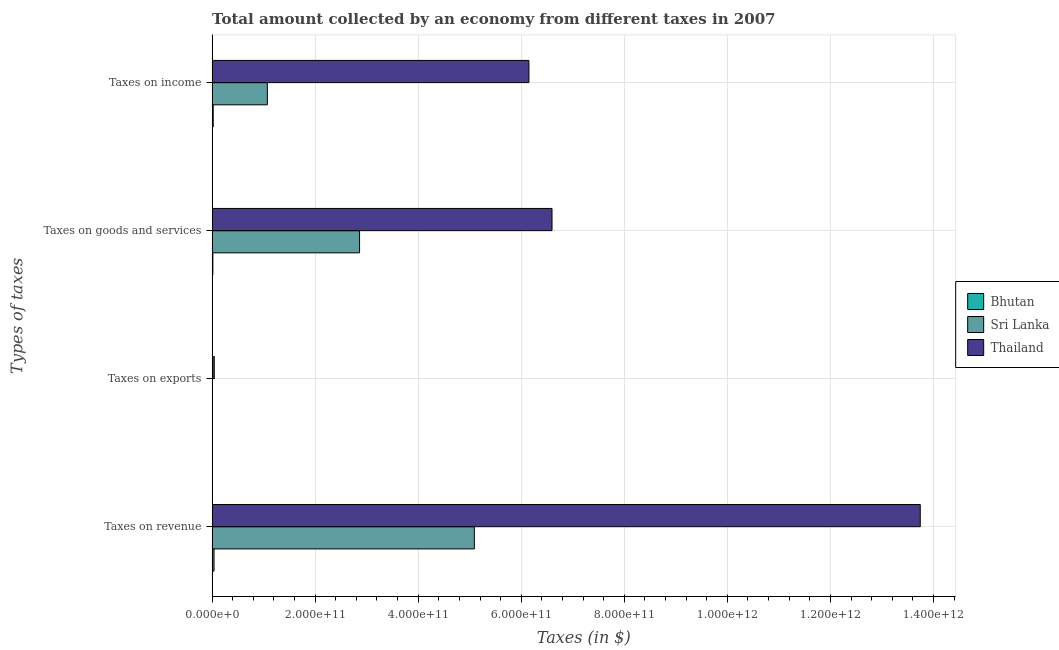How many different coloured bars are there?
Make the answer very short. 3. How many bars are there on the 2nd tick from the top?
Provide a succinct answer. 3. How many bars are there on the 1st tick from the bottom?
Provide a short and direct response. 3. What is the label of the 2nd group of bars from the top?
Ensure brevity in your answer.  Taxes on goods and services. What is the amount collected as tax on revenue in Thailand?
Offer a very short reply. 1.37e+12. Across all countries, what is the maximum amount collected as tax on exports?
Your answer should be compact. 4.16e+09. Across all countries, what is the minimum amount collected as tax on goods?
Offer a terse response. 1.42e+09. In which country was the amount collected as tax on revenue maximum?
Provide a short and direct response. Thailand. In which country was the amount collected as tax on exports minimum?
Your answer should be compact. Bhutan. What is the total amount collected as tax on goods in the graph?
Your answer should be compact. 9.47e+11. What is the difference between the amount collected as tax on exports in Thailand and that in Bhutan?
Offer a very short reply. 4.16e+09. What is the difference between the amount collected as tax on exports in Thailand and the amount collected as tax on income in Sri Lanka?
Your response must be concise. -1.03e+11. What is the average amount collected as tax on revenue per country?
Keep it short and to the point. 6.29e+11. What is the difference between the amount collected as tax on goods and amount collected as tax on revenue in Thailand?
Keep it short and to the point. -7.15e+11. In how many countries, is the amount collected as tax on goods greater than 1040000000000 $?
Provide a short and direct response. 0. What is the ratio of the amount collected as tax on revenue in Thailand to that in Sri Lanka?
Offer a terse response. 2.7. What is the difference between the highest and the second highest amount collected as tax on income?
Give a very brief answer. 5.08e+11. What is the difference between the highest and the lowest amount collected as tax on exports?
Ensure brevity in your answer.  4.16e+09. In how many countries, is the amount collected as tax on exports greater than the average amount collected as tax on exports taken over all countries?
Your answer should be very brief. 1. Is the sum of the amount collected as tax on revenue in Bhutan and Sri Lanka greater than the maximum amount collected as tax on goods across all countries?
Give a very brief answer. No. Is it the case that in every country, the sum of the amount collected as tax on goods and amount collected as tax on income is greater than the sum of amount collected as tax on exports and amount collected as tax on revenue?
Keep it short and to the point. No. What does the 2nd bar from the top in Taxes on exports represents?
Make the answer very short. Sri Lanka. What does the 3rd bar from the bottom in Taxes on revenue represents?
Provide a succinct answer. Thailand. What is the difference between two consecutive major ticks on the X-axis?
Your answer should be very brief. 2.00e+11. Does the graph contain any zero values?
Your response must be concise. No. How many legend labels are there?
Your response must be concise. 3. How are the legend labels stacked?
Make the answer very short. Vertical. What is the title of the graph?
Offer a terse response. Total amount collected by an economy from different taxes in 2007. Does "Venezuela" appear as one of the legend labels in the graph?
Your response must be concise. No. What is the label or title of the X-axis?
Give a very brief answer. Taxes (in $). What is the label or title of the Y-axis?
Make the answer very short. Types of taxes. What is the Taxes (in $) in Bhutan in Taxes on revenue?
Keep it short and to the point. 3.72e+09. What is the Taxes (in $) of Sri Lanka in Taxes on revenue?
Ensure brevity in your answer.  5.09e+11. What is the Taxes (in $) in Thailand in Taxes on revenue?
Your answer should be very brief. 1.37e+12. What is the Taxes (in $) of Bhutan in Taxes on exports?
Your answer should be very brief. 1.20e+04. What is the Taxes (in $) in Sri Lanka in Taxes on exports?
Your answer should be compact. 3.30e+07. What is the Taxes (in $) of Thailand in Taxes on exports?
Offer a very short reply. 4.16e+09. What is the Taxes (in $) of Bhutan in Taxes on goods and services?
Provide a succinct answer. 1.42e+09. What is the Taxes (in $) in Sri Lanka in Taxes on goods and services?
Ensure brevity in your answer.  2.86e+11. What is the Taxes (in $) of Thailand in Taxes on goods and services?
Make the answer very short. 6.60e+11. What is the Taxes (in $) in Bhutan in Taxes on income?
Your response must be concise. 2.11e+09. What is the Taxes (in $) of Sri Lanka in Taxes on income?
Provide a short and direct response. 1.07e+11. What is the Taxes (in $) in Thailand in Taxes on income?
Offer a very short reply. 6.15e+11. Across all Types of taxes, what is the maximum Taxes (in $) of Bhutan?
Make the answer very short. 3.72e+09. Across all Types of taxes, what is the maximum Taxes (in $) in Sri Lanka?
Give a very brief answer. 5.09e+11. Across all Types of taxes, what is the maximum Taxes (in $) in Thailand?
Make the answer very short. 1.37e+12. Across all Types of taxes, what is the minimum Taxes (in $) of Bhutan?
Offer a very short reply. 1.20e+04. Across all Types of taxes, what is the minimum Taxes (in $) of Sri Lanka?
Provide a succinct answer. 3.30e+07. Across all Types of taxes, what is the minimum Taxes (in $) in Thailand?
Offer a very short reply. 4.16e+09. What is the total Taxes (in $) in Bhutan in the graph?
Provide a short and direct response. 7.25e+09. What is the total Taxes (in $) of Sri Lanka in the graph?
Offer a very short reply. 9.02e+11. What is the total Taxes (in $) in Thailand in the graph?
Ensure brevity in your answer.  2.65e+12. What is the difference between the Taxes (in $) in Bhutan in Taxes on revenue and that in Taxes on exports?
Provide a succinct answer. 3.72e+09. What is the difference between the Taxes (in $) of Sri Lanka in Taxes on revenue and that in Taxes on exports?
Provide a short and direct response. 5.09e+11. What is the difference between the Taxes (in $) in Thailand in Taxes on revenue and that in Taxes on exports?
Provide a short and direct response. 1.37e+12. What is the difference between the Taxes (in $) of Bhutan in Taxes on revenue and that in Taxes on goods and services?
Provide a succinct answer. 2.30e+09. What is the difference between the Taxes (in $) of Sri Lanka in Taxes on revenue and that in Taxes on goods and services?
Make the answer very short. 2.23e+11. What is the difference between the Taxes (in $) of Thailand in Taxes on revenue and that in Taxes on goods and services?
Keep it short and to the point. 7.15e+11. What is the difference between the Taxes (in $) of Bhutan in Taxes on revenue and that in Taxes on income?
Offer a very short reply. 1.61e+09. What is the difference between the Taxes (in $) in Sri Lanka in Taxes on revenue and that in Taxes on income?
Give a very brief answer. 4.02e+11. What is the difference between the Taxes (in $) in Thailand in Taxes on revenue and that in Taxes on income?
Your answer should be very brief. 7.60e+11. What is the difference between the Taxes (in $) in Bhutan in Taxes on exports and that in Taxes on goods and services?
Keep it short and to the point. -1.42e+09. What is the difference between the Taxes (in $) of Sri Lanka in Taxes on exports and that in Taxes on goods and services?
Your answer should be compact. -2.86e+11. What is the difference between the Taxes (in $) in Thailand in Taxes on exports and that in Taxes on goods and services?
Offer a very short reply. -6.56e+11. What is the difference between the Taxes (in $) in Bhutan in Taxes on exports and that in Taxes on income?
Make the answer very short. -2.11e+09. What is the difference between the Taxes (in $) of Sri Lanka in Taxes on exports and that in Taxes on income?
Your answer should be very brief. -1.07e+11. What is the difference between the Taxes (in $) in Thailand in Taxes on exports and that in Taxes on income?
Your response must be concise. -6.11e+11. What is the difference between the Taxes (in $) of Bhutan in Taxes on goods and services and that in Taxes on income?
Offer a terse response. -6.85e+08. What is the difference between the Taxes (in $) in Sri Lanka in Taxes on goods and services and that in Taxes on income?
Offer a very short reply. 1.79e+11. What is the difference between the Taxes (in $) in Thailand in Taxes on goods and services and that in Taxes on income?
Provide a short and direct response. 4.48e+1. What is the difference between the Taxes (in $) in Bhutan in Taxes on revenue and the Taxes (in $) in Sri Lanka in Taxes on exports?
Give a very brief answer. 3.69e+09. What is the difference between the Taxes (in $) in Bhutan in Taxes on revenue and the Taxes (in $) in Thailand in Taxes on exports?
Make the answer very short. -4.45e+08. What is the difference between the Taxes (in $) in Sri Lanka in Taxes on revenue and the Taxes (in $) in Thailand in Taxes on exports?
Provide a succinct answer. 5.05e+11. What is the difference between the Taxes (in $) in Bhutan in Taxes on revenue and the Taxes (in $) in Sri Lanka in Taxes on goods and services?
Your response must be concise. -2.82e+11. What is the difference between the Taxes (in $) in Bhutan in Taxes on revenue and the Taxes (in $) in Thailand in Taxes on goods and services?
Provide a succinct answer. -6.56e+11. What is the difference between the Taxes (in $) in Sri Lanka in Taxes on revenue and the Taxes (in $) in Thailand in Taxes on goods and services?
Your answer should be very brief. -1.51e+11. What is the difference between the Taxes (in $) of Bhutan in Taxes on revenue and the Taxes (in $) of Sri Lanka in Taxes on income?
Your answer should be compact. -1.03e+11. What is the difference between the Taxes (in $) of Bhutan in Taxes on revenue and the Taxes (in $) of Thailand in Taxes on income?
Provide a short and direct response. -6.11e+11. What is the difference between the Taxes (in $) of Sri Lanka in Taxes on revenue and the Taxes (in $) of Thailand in Taxes on income?
Your response must be concise. -1.06e+11. What is the difference between the Taxes (in $) in Bhutan in Taxes on exports and the Taxes (in $) in Sri Lanka in Taxes on goods and services?
Make the answer very short. -2.86e+11. What is the difference between the Taxes (in $) in Bhutan in Taxes on exports and the Taxes (in $) in Thailand in Taxes on goods and services?
Your response must be concise. -6.60e+11. What is the difference between the Taxes (in $) of Sri Lanka in Taxes on exports and the Taxes (in $) of Thailand in Taxes on goods and services?
Your response must be concise. -6.60e+11. What is the difference between the Taxes (in $) of Bhutan in Taxes on exports and the Taxes (in $) of Sri Lanka in Taxes on income?
Give a very brief answer. -1.07e+11. What is the difference between the Taxes (in $) of Bhutan in Taxes on exports and the Taxes (in $) of Thailand in Taxes on income?
Offer a very short reply. -6.15e+11. What is the difference between the Taxes (in $) in Sri Lanka in Taxes on exports and the Taxes (in $) in Thailand in Taxes on income?
Give a very brief answer. -6.15e+11. What is the difference between the Taxes (in $) in Bhutan in Taxes on goods and services and the Taxes (in $) in Sri Lanka in Taxes on income?
Ensure brevity in your answer.  -1.06e+11. What is the difference between the Taxes (in $) in Bhutan in Taxes on goods and services and the Taxes (in $) in Thailand in Taxes on income?
Make the answer very short. -6.13e+11. What is the difference between the Taxes (in $) of Sri Lanka in Taxes on goods and services and the Taxes (in $) of Thailand in Taxes on income?
Your answer should be very brief. -3.29e+11. What is the average Taxes (in $) in Bhutan per Types of taxes?
Provide a succinct answer. 1.81e+09. What is the average Taxes (in $) in Sri Lanka per Types of taxes?
Your response must be concise. 2.26e+11. What is the average Taxes (in $) in Thailand per Types of taxes?
Your response must be concise. 6.63e+11. What is the difference between the Taxes (in $) in Bhutan and Taxes (in $) in Sri Lanka in Taxes on revenue?
Make the answer very short. -5.05e+11. What is the difference between the Taxes (in $) in Bhutan and Taxes (in $) in Thailand in Taxes on revenue?
Give a very brief answer. -1.37e+12. What is the difference between the Taxes (in $) of Sri Lanka and Taxes (in $) of Thailand in Taxes on revenue?
Ensure brevity in your answer.  -8.65e+11. What is the difference between the Taxes (in $) in Bhutan and Taxes (in $) in Sri Lanka in Taxes on exports?
Keep it short and to the point. -3.30e+07. What is the difference between the Taxes (in $) of Bhutan and Taxes (in $) of Thailand in Taxes on exports?
Provide a short and direct response. -4.16e+09. What is the difference between the Taxes (in $) in Sri Lanka and Taxes (in $) in Thailand in Taxes on exports?
Provide a succinct answer. -4.13e+09. What is the difference between the Taxes (in $) of Bhutan and Taxes (in $) of Sri Lanka in Taxes on goods and services?
Offer a very short reply. -2.85e+11. What is the difference between the Taxes (in $) in Bhutan and Taxes (in $) in Thailand in Taxes on goods and services?
Give a very brief answer. -6.58e+11. What is the difference between the Taxes (in $) in Sri Lanka and Taxes (in $) in Thailand in Taxes on goods and services?
Make the answer very short. -3.74e+11. What is the difference between the Taxes (in $) in Bhutan and Taxes (in $) in Sri Lanka in Taxes on income?
Give a very brief answer. -1.05e+11. What is the difference between the Taxes (in $) of Bhutan and Taxes (in $) of Thailand in Taxes on income?
Provide a succinct answer. -6.13e+11. What is the difference between the Taxes (in $) of Sri Lanka and Taxes (in $) of Thailand in Taxes on income?
Ensure brevity in your answer.  -5.08e+11. What is the ratio of the Taxes (in $) in Bhutan in Taxes on revenue to that in Taxes on exports?
Give a very brief answer. 3.10e+05. What is the ratio of the Taxes (in $) of Sri Lanka in Taxes on revenue to that in Taxes on exports?
Give a very brief answer. 1.54e+04. What is the ratio of the Taxes (in $) in Thailand in Taxes on revenue to that in Taxes on exports?
Provide a short and direct response. 330.06. What is the ratio of the Taxes (in $) in Bhutan in Taxes on revenue to that in Taxes on goods and services?
Ensure brevity in your answer.  2.61. What is the ratio of the Taxes (in $) in Sri Lanka in Taxes on revenue to that in Taxes on goods and services?
Your answer should be very brief. 1.78. What is the ratio of the Taxes (in $) of Thailand in Taxes on revenue to that in Taxes on goods and services?
Make the answer very short. 2.08. What is the ratio of the Taxes (in $) of Bhutan in Taxes on revenue to that in Taxes on income?
Keep it short and to the point. 1.76. What is the ratio of the Taxes (in $) of Sri Lanka in Taxes on revenue to that in Taxes on income?
Offer a terse response. 4.75. What is the ratio of the Taxes (in $) of Thailand in Taxes on revenue to that in Taxes on income?
Offer a terse response. 2.24. What is the ratio of the Taxes (in $) of Bhutan in Taxes on exports to that in Taxes on goods and services?
Provide a succinct answer. 0. What is the ratio of the Taxes (in $) of Sri Lanka in Taxes on exports to that in Taxes on goods and services?
Your answer should be compact. 0. What is the ratio of the Taxes (in $) in Thailand in Taxes on exports to that in Taxes on goods and services?
Offer a terse response. 0.01. What is the ratio of the Taxes (in $) of Bhutan in Taxes on exports to that in Taxes on income?
Offer a very short reply. 0. What is the ratio of the Taxes (in $) in Sri Lanka in Taxes on exports to that in Taxes on income?
Give a very brief answer. 0. What is the ratio of the Taxes (in $) of Thailand in Taxes on exports to that in Taxes on income?
Your answer should be compact. 0.01. What is the ratio of the Taxes (in $) of Bhutan in Taxes on goods and services to that in Taxes on income?
Your answer should be compact. 0.68. What is the ratio of the Taxes (in $) in Sri Lanka in Taxes on goods and services to that in Taxes on income?
Your answer should be very brief. 2.67. What is the ratio of the Taxes (in $) of Thailand in Taxes on goods and services to that in Taxes on income?
Provide a succinct answer. 1.07. What is the difference between the highest and the second highest Taxes (in $) of Bhutan?
Your answer should be compact. 1.61e+09. What is the difference between the highest and the second highest Taxes (in $) of Sri Lanka?
Make the answer very short. 2.23e+11. What is the difference between the highest and the second highest Taxes (in $) of Thailand?
Keep it short and to the point. 7.15e+11. What is the difference between the highest and the lowest Taxes (in $) in Bhutan?
Your answer should be very brief. 3.72e+09. What is the difference between the highest and the lowest Taxes (in $) in Sri Lanka?
Keep it short and to the point. 5.09e+11. What is the difference between the highest and the lowest Taxes (in $) in Thailand?
Your response must be concise. 1.37e+12. 